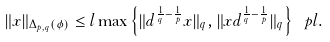Convert formula to latex. <formula><loc_0><loc_0><loc_500><loc_500>\| x \| _ { \Delta _ { p , q } ( \phi ) } \leq l \max \left \{ \| d ^ { \frac { 1 } { q } - \frac { 1 } { p } } x \| _ { q } , \| x d ^ { \frac { 1 } { q } - \frac { 1 } { p } } \| _ { q } \right \} \ p l .</formula> 